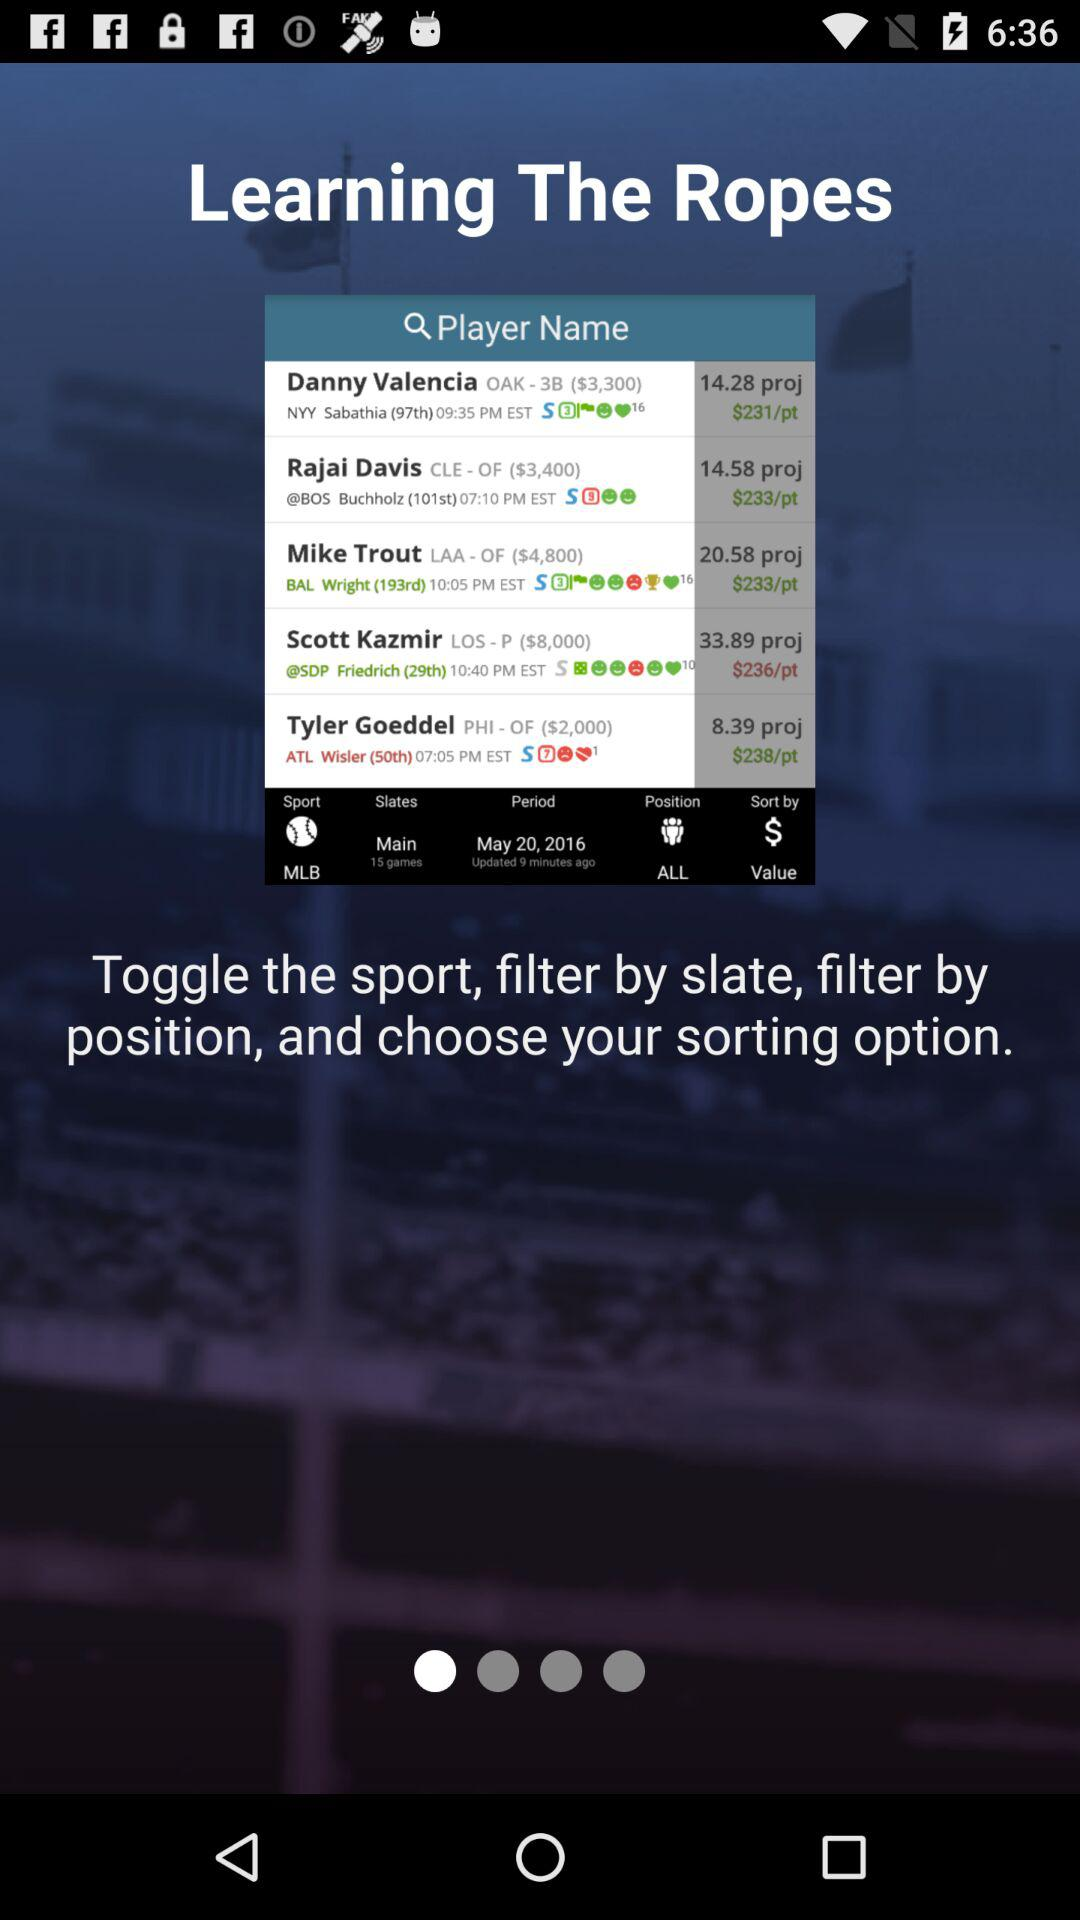How many dollars per point are there for Danny? There are $231 per point for Danny. 